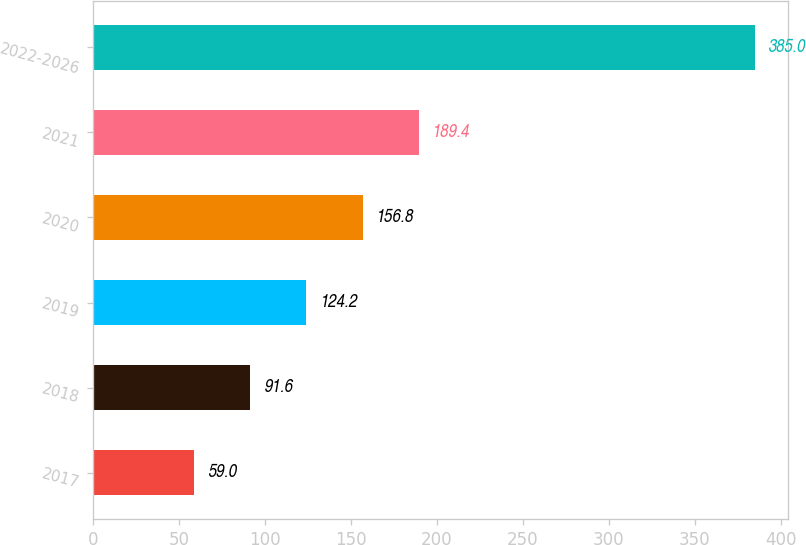Convert chart to OTSL. <chart><loc_0><loc_0><loc_500><loc_500><bar_chart><fcel>2017<fcel>2018<fcel>2019<fcel>2020<fcel>2021<fcel>2022-2026<nl><fcel>59<fcel>91.6<fcel>124.2<fcel>156.8<fcel>189.4<fcel>385<nl></chart> 